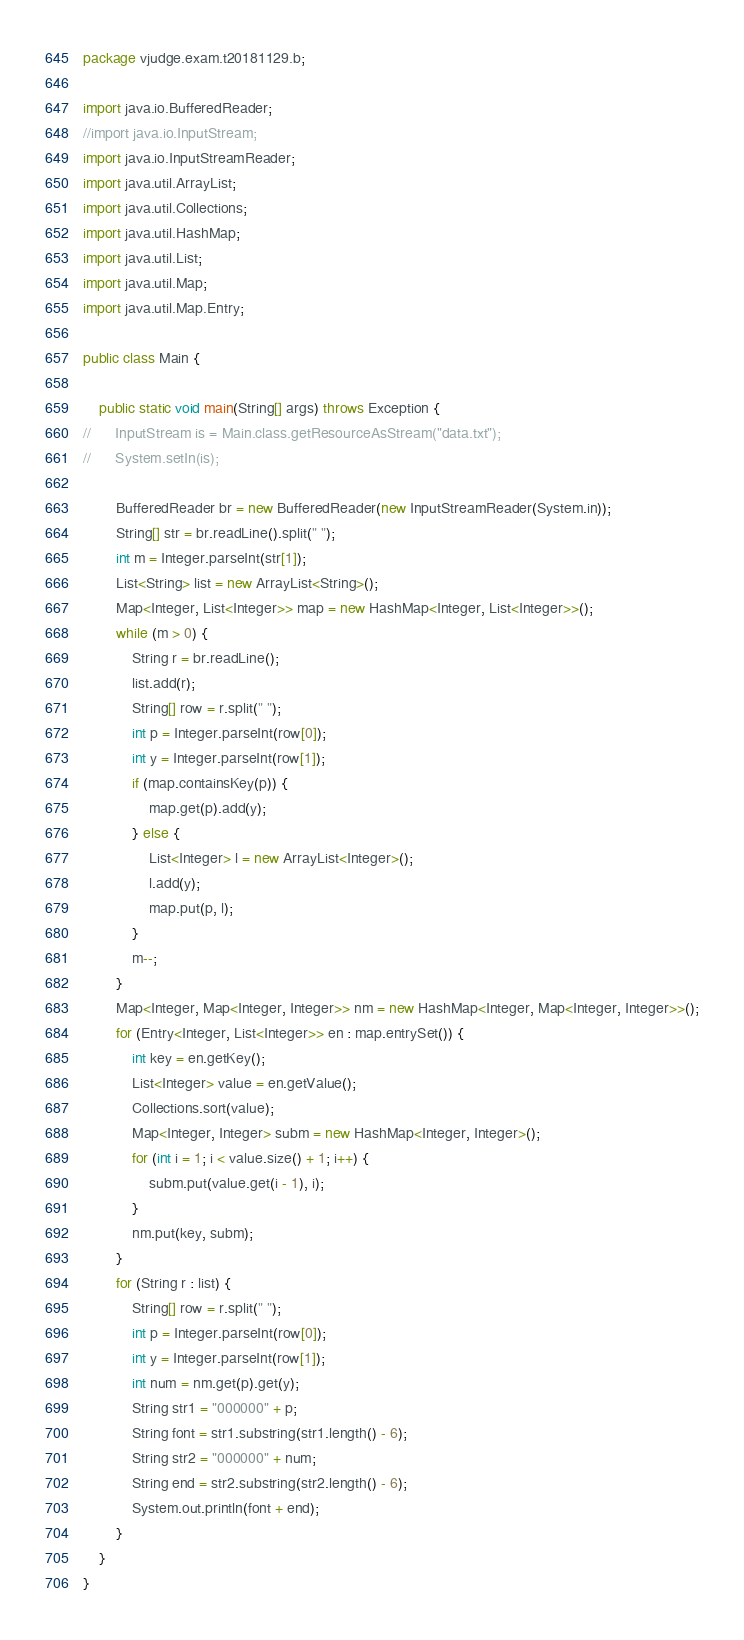Convert code to text. <code><loc_0><loc_0><loc_500><loc_500><_Java_>package vjudge.exam.t20181129.b;

import java.io.BufferedReader;
//import java.io.InputStream;
import java.io.InputStreamReader;
import java.util.ArrayList;
import java.util.Collections;
import java.util.HashMap;
import java.util.List;
import java.util.Map;
import java.util.Map.Entry;

public class Main {

	public static void main(String[] args) throws Exception {
//		InputStream is = Main.class.getResourceAsStream("data.txt");
//		System.setIn(is);

		BufferedReader br = new BufferedReader(new InputStreamReader(System.in));
		String[] str = br.readLine().split(" ");
		int m = Integer.parseInt(str[1]);
		List<String> list = new ArrayList<String>();
		Map<Integer, List<Integer>> map = new HashMap<Integer, List<Integer>>();
		while (m > 0) {
			String r = br.readLine();
			list.add(r);
			String[] row = r.split(" ");
			int p = Integer.parseInt(row[0]);
			int y = Integer.parseInt(row[1]);
			if (map.containsKey(p)) {
				map.get(p).add(y);
			} else {
				List<Integer> l = new ArrayList<Integer>();
				l.add(y);
				map.put(p, l);
			}
			m--;
		}
		Map<Integer, Map<Integer, Integer>> nm = new HashMap<Integer, Map<Integer, Integer>>();
		for (Entry<Integer, List<Integer>> en : map.entrySet()) {
			int key = en.getKey();
			List<Integer> value = en.getValue();
			Collections.sort(value);
			Map<Integer, Integer> subm = new HashMap<Integer, Integer>();
			for (int i = 1; i < value.size() + 1; i++) {
				subm.put(value.get(i - 1), i);
			}
			nm.put(key, subm);
		}
		for (String r : list) {
			String[] row = r.split(" ");
			int p = Integer.parseInt(row[0]);
			int y = Integer.parseInt(row[1]);
			int num = nm.get(p).get(y);
			String str1 = "000000" + p;
			String font = str1.substring(str1.length() - 6);
			String str2 = "000000" + num;
			String end = str2.substring(str2.length() - 6);
			System.out.println(font + end);
		}
	}
}
</code> 